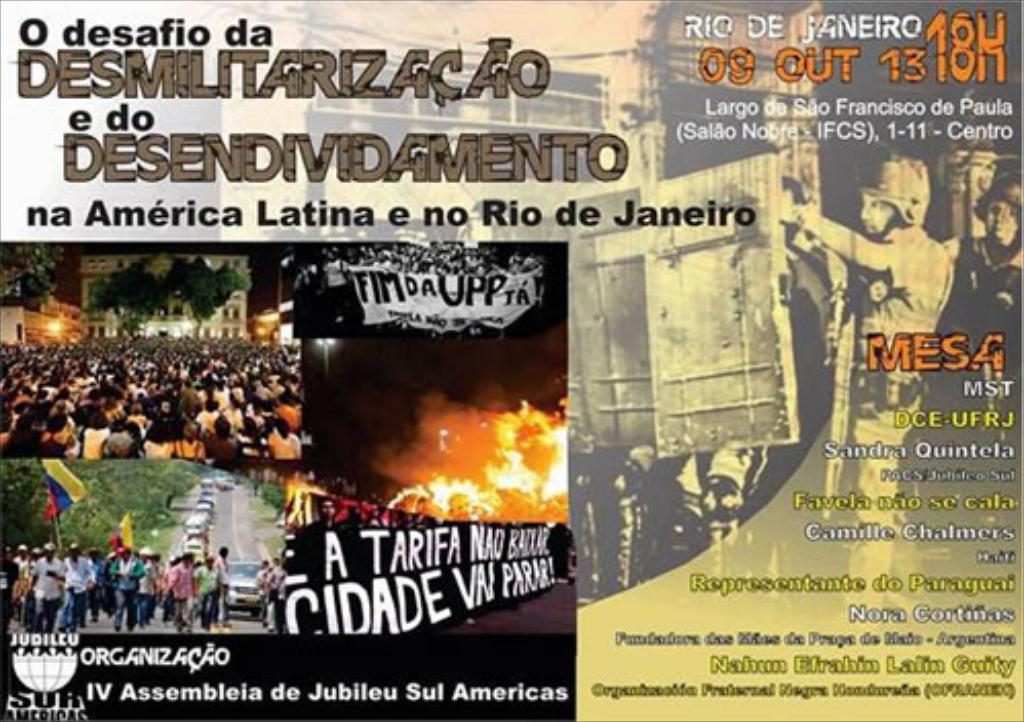What can you infer about the objective of the protests depicted in this image? The posters allude to issues like demilitarization and debt relief in Latin America and Rio de Janeiro, indicating a mobilization against security policies and economic conditions that affect the region. It suggests a collective call for social justice and policy reforms. 